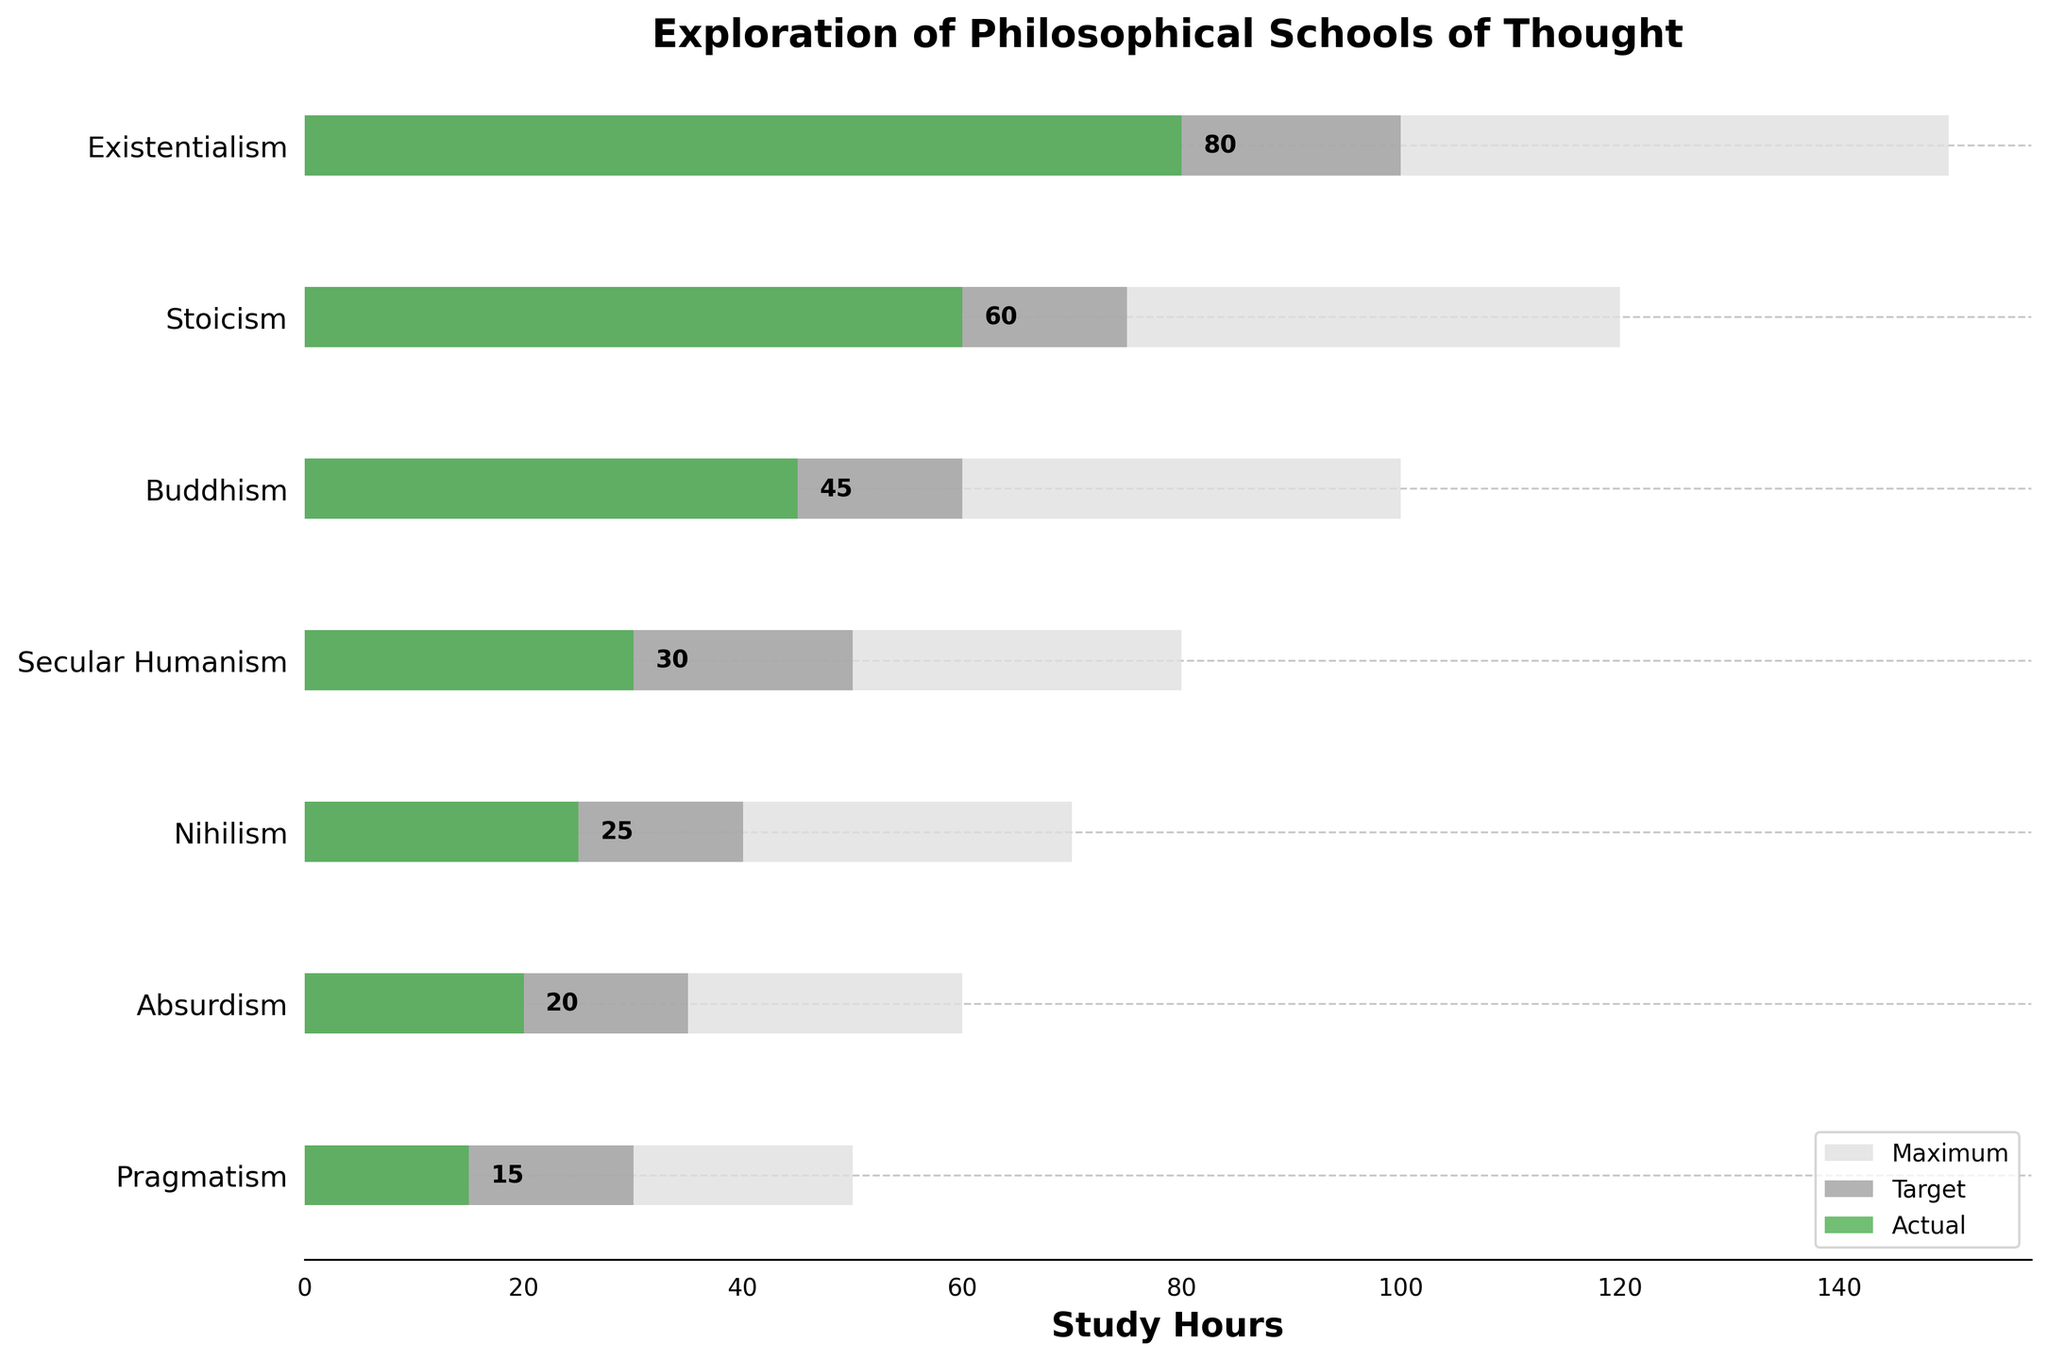What's the title of the figure? The title of the figure is typically found at the top, center position of the chart and it summarises the main theme visualized. The title of this figure is "Exploration of Philosophical Schools of Thought".
Answer: Exploration of Philosophical Schools of Thought Which philosophical school has the highest actual study hours? To determine the school with the highest actual study hours, look at the bars representing the 'Actual' study hours and identify the longest one. Existentialism has the highest actual study hours.
Answer: Existentialism How much more time was spent on Existentialism compared to Stoicism? This requires comparing the actual study hours of Existentialism and Stoicism. Existentialism has 80 hours and Stoicism has 60 hours. Subtract 60 from 80 to find the difference.
Answer: 20 hours What is the target study hours for Buddhism? The target study hours for Buddhism can be found on the chart by locating Buddhism on the y-axis and checking the grey-colored bar labeled 'Target'.
Answer: 60 hours By how many hours did Absurdism fall short of its target study hours? Look at the actual and target bars for Absurdism. The actual hours are 20 and the target is 35. Subtract 20 from 35 to find the shortfall.
Answer: 15 hours Which philosophical schools did not reach their target study hours? Identify the schools where the actual study hours bar is shorter than the target study hours bar. All listed schools (Existentialism, Stoicism, Buddhism, Secular Humanism, Nihilism, Absurdism, Pragmatism) did not meet their targets.
Answer: Existentialism, Stoicism, Buddhism, Secular Humanism, Nihilism, Absurdism, Pragmatism Which school of thought had the smallest gap between actual and target study hours? Calculate the difference between actual and target study hours for each school and identify the smallest difference. Existentialism has the smallest gap (100 - 80 = 20 hours).
Answer: Existentialism Compare the actual study hours of Secular Humanism and Nihilism. Which one is higher and by how much? Look at the actual study hours for Secular Humanism (30 hours) and Nihilism (25 hours). Subtract the smaller value from the greater one. Secular Humanism has 5 more hours.
Answer: Secular Humanism by 5 hours What's the combined study hours dedicated to Absurdism and Pragmatism? Add the actual study hours for Absurdism (20 hours) and Pragmatism (15 hours).
Answer: 35 hours What’s the total maximum potential study hours for all philosophical schools combined? Add the maximum study hours for all schools: 150 (Existentialism) + 120 (Stoicism) + 100 (Buddhism) + 80 (Secular Humanism) + 70 (Nihilism) + 60 (Absurdism) + 50 (Pragmatism)
Answer: 630 hours 